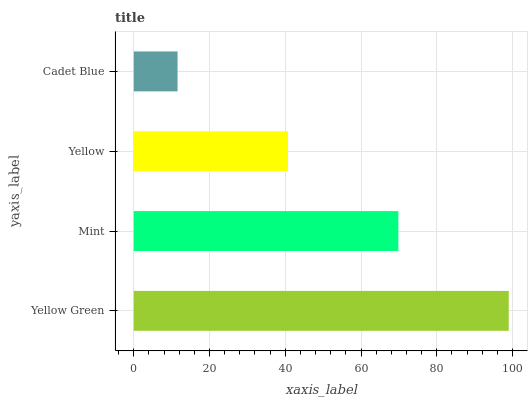Is Cadet Blue the minimum?
Answer yes or no. Yes. Is Yellow Green the maximum?
Answer yes or no. Yes. Is Mint the minimum?
Answer yes or no. No. Is Mint the maximum?
Answer yes or no. No. Is Yellow Green greater than Mint?
Answer yes or no. Yes. Is Mint less than Yellow Green?
Answer yes or no. Yes. Is Mint greater than Yellow Green?
Answer yes or no. No. Is Yellow Green less than Mint?
Answer yes or no. No. Is Mint the high median?
Answer yes or no. Yes. Is Yellow the low median?
Answer yes or no. Yes. Is Yellow Green the high median?
Answer yes or no. No. Is Yellow Green the low median?
Answer yes or no. No. 